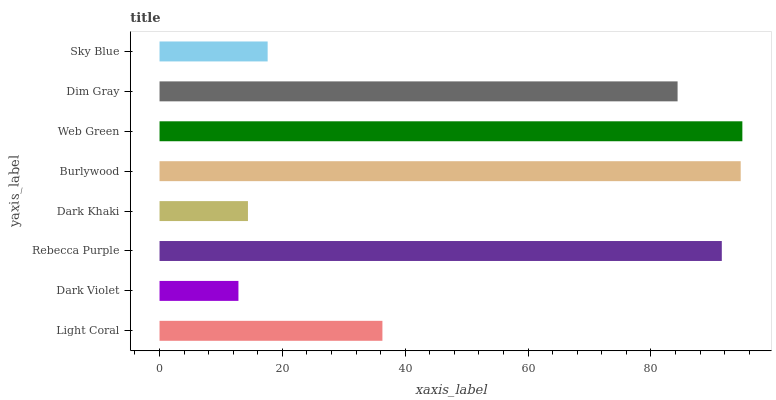Is Dark Violet the minimum?
Answer yes or no. Yes. Is Web Green the maximum?
Answer yes or no. Yes. Is Rebecca Purple the minimum?
Answer yes or no. No. Is Rebecca Purple the maximum?
Answer yes or no. No. Is Rebecca Purple greater than Dark Violet?
Answer yes or no. Yes. Is Dark Violet less than Rebecca Purple?
Answer yes or no. Yes. Is Dark Violet greater than Rebecca Purple?
Answer yes or no. No. Is Rebecca Purple less than Dark Violet?
Answer yes or no. No. Is Dim Gray the high median?
Answer yes or no. Yes. Is Light Coral the low median?
Answer yes or no. Yes. Is Rebecca Purple the high median?
Answer yes or no. No. Is Burlywood the low median?
Answer yes or no. No. 